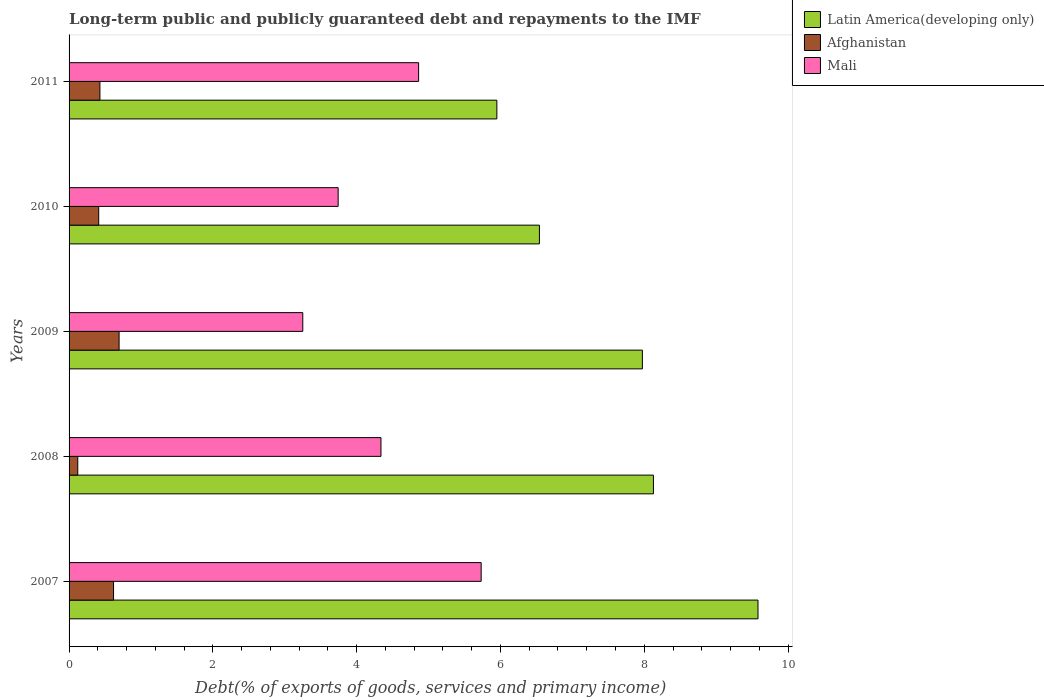How many groups of bars are there?
Make the answer very short. 5. Are the number of bars on each tick of the Y-axis equal?
Keep it short and to the point. Yes. What is the debt and repayments in Mali in 2007?
Keep it short and to the point. 5.73. Across all years, what is the maximum debt and repayments in Afghanistan?
Keep it short and to the point. 0.7. Across all years, what is the minimum debt and repayments in Latin America(developing only)?
Keep it short and to the point. 5.95. In which year was the debt and repayments in Mali maximum?
Provide a succinct answer. 2007. What is the total debt and repayments in Mali in the graph?
Offer a terse response. 21.92. What is the difference between the debt and repayments in Afghanistan in 2009 and that in 2011?
Your answer should be very brief. 0.27. What is the difference between the debt and repayments in Afghanistan in 2008 and the debt and repayments in Mali in 2007?
Ensure brevity in your answer.  -5.61. What is the average debt and repayments in Latin America(developing only) per year?
Your answer should be compact. 7.63. In the year 2009, what is the difference between the debt and repayments in Mali and debt and repayments in Latin America(developing only)?
Offer a terse response. -4.72. In how many years, is the debt and repayments in Afghanistan greater than 7.2 %?
Offer a terse response. 0. What is the ratio of the debt and repayments in Mali in 2008 to that in 2010?
Offer a terse response. 1.16. Is the difference between the debt and repayments in Mali in 2008 and 2009 greater than the difference between the debt and repayments in Latin America(developing only) in 2008 and 2009?
Provide a short and direct response. Yes. What is the difference between the highest and the second highest debt and repayments in Mali?
Your answer should be compact. 0.87. What is the difference between the highest and the lowest debt and repayments in Afghanistan?
Offer a terse response. 0.57. In how many years, is the debt and repayments in Afghanistan greater than the average debt and repayments in Afghanistan taken over all years?
Keep it short and to the point. 2. Is the sum of the debt and repayments in Latin America(developing only) in 2008 and 2010 greater than the maximum debt and repayments in Afghanistan across all years?
Ensure brevity in your answer.  Yes. What does the 1st bar from the top in 2010 represents?
Offer a very short reply. Mali. What does the 1st bar from the bottom in 2009 represents?
Your answer should be very brief. Latin America(developing only). How many bars are there?
Provide a succinct answer. 15. Where does the legend appear in the graph?
Keep it short and to the point. Top right. How are the legend labels stacked?
Make the answer very short. Vertical. What is the title of the graph?
Give a very brief answer. Long-term public and publicly guaranteed debt and repayments to the IMF. Does "Israel" appear as one of the legend labels in the graph?
Keep it short and to the point. No. What is the label or title of the X-axis?
Your answer should be very brief. Debt(% of exports of goods, services and primary income). What is the label or title of the Y-axis?
Give a very brief answer. Years. What is the Debt(% of exports of goods, services and primary income) of Latin America(developing only) in 2007?
Provide a short and direct response. 9.58. What is the Debt(% of exports of goods, services and primary income) of Afghanistan in 2007?
Your answer should be compact. 0.62. What is the Debt(% of exports of goods, services and primary income) of Mali in 2007?
Ensure brevity in your answer.  5.73. What is the Debt(% of exports of goods, services and primary income) of Latin America(developing only) in 2008?
Your response must be concise. 8.13. What is the Debt(% of exports of goods, services and primary income) in Afghanistan in 2008?
Make the answer very short. 0.12. What is the Debt(% of exports of goods, services and primary income) in Mali in 2008?
Your answer should be compact. 4.34. What is the Debt(% of exports of goods, services and primary income) of Latin America(developing only) in 2009?
Offer a terse response. 7.97. What is the Debt(% of exports of goods, services and primary income) in Afghanistan in 2009?
Make the answer very short. 0.7. What is the Debt(% of exports of goods, services and primary income) in Mali in 2009?
Offer a terse response. 3.25. What is the Debt(% of exports of goods, services and primary income) of Latin America(developing only) in 2010?
Provide a short and direct response. 6.54. What is the Debt(% of exports of goods, services and primary income) in Afghanistan in 2010?
Provide a succinct answer. 0.41. What is the Debt(% of exports of goods, services and primary income) of Mali in 2010?
Ensure brevity in your answer.  3.74. What is the Debt(% of exports of goods, services and primary income) of Latin America(developing only) in 2011?
Your response must be concise. 5.95. What is the Debt(% of exports of goods, services and primary income) in Afghanistan in 2011?
Make the answer very short. 0.43. What is the Debt(% of exports of goods, services and primary income) of Mali in 2011?
Your answer should be compact. 4.86. Across all years, what is the maximum Debt(% of exports of goods, services and primary income) in Latin America(developing only)?
Make the answer very short. 9.58. Across all years, what is the maximum Debt(% of exports of goods, services and primary income) in Afghanistan?
Your response must be concise. 0.7. Across all years, what is the maximum Debt(% of exports of goods, services and primary income) of Mali?
Your answer should be compact. 5.73. Across all years, what is the minimum Debt(% of exports of goods, services and primary income) of Latin America(developing only)?
Ensure brevity in your answer.  5.95. Across all years, what is the minimum Debt(% of exports of goods, services and primary income) in Afghanistan?
Provide a succinct answer. 0.12. Across all years, what is the minimum Debt(% of exports of goods, services and primary income) of Mali?
Give a very brief answer. 3.25. What is the total Debt(% of exports of goods, services and primary income) in Latin America(developing only) in the graph?
Make the answer very short. 38.17. What is the total Debt(% of exports of goods, services and primary income) in Afghanistan in the graph?
Your response must be concise. 2.28. What is the total Debt(% of exports of goods, services and primary income) of Mali in the graph?
Provide a succinct answer. 21.92. What is the difference between the Debt(% of exports of goods, services and primary income) in Latin America(developing only) in 2007 and that in 2008?
Provide a short and direct response. 1.45. What is the difference between the Debt(% of exports of goods, services and primary income) of Afghanistan in 2007 and that in 2008?
Provide a succinct answer. 0.5. What is the difference between the Debt(% of exports of goods, services and primary income) of Mali in 2007 and that in 2008?
Your answer should be compact. 1.39. What is the difference between the Debt(% of exports of goods, services and primary income) of Latin America(developing only) in 2007 and that in 2009?
Provide a short and direct response. 1.61. What is the difference between the Debt(% of exports of goods, services and primary income) in Afghanistan in 2007 and that in 2009?
Your answer should be very brief. -0.08. What is the difference between the Debt(% of exports of goods, services and primary income) of Mali in 2007 and that in 2009?
Your answer should be compact. 2.48. What is the difference between the Debt(% of exports of goods, services and primary income) in Latin America(developing only) in 2007 and that in 2010?
Your response must be concise. 3.04. What is the difference between the Debt(% of exports of goods, services and primary income) in Afghanistan in 2007 and that in 2010?
Your answer should be compact. 0.21. What is the difference between the Debt(% of exports of goods, services and primary income) of Mali in 2007 and that in 2010?
Provide a succinct answer. 1.99. What is the difference between the Debt(% of exports of goods, services and primary income) of Latin America(developing only) in 2007 and that in 2011?
Provide a short and direct response. 3.63. What is the difference between the Debt(% of exports of goods, services and primary income) of Afghanistan in 2007 and that in 2011?
Make the answer very short. 0.19. What is the difference between the Debt(% of exports of goods, services and primary income) in Mali in 2007 and that in 2011?
Your answer should be compact. 0.87. What is the difference between the Debt(% of exports of goods, services and primary income) of Latin America(developing only) in 2008 and that in 2009?
Provide a short and direct response. 0.15. What is the difference between the Debt(% of exports of goods, services and primary income) in Afghanistan in 2008 and that in 2009?
Offer a terse response. -0.57. What is the difference between the Debt(% of exports of goods, services and primary income) of Mali in 2008 and that in 2009?
Keep it short and to the point. 1.09. What is the difference between the Debt(% of exports of goods, services and primary income) of Latin America(developing only) in 2008 and that in 2010?
Ensure brevity in your answer.  1.59. What is the difference between the Debt(% of exports of goods, services and primary income) in Afghanistan in 2008 and that in 2010?
Provide a short and direct response. -0.29. What is the difference between the Debt(% of exports of goods, services and primary income) in Mali in 2008 and that in 2010?
Provide a succinct answer. 0.6. What is the difference between the Debt(% of exports of goods, services and primary income) in Latin America(developing only) in 2008 and that in 2011?
Your answer should be compact. 2.18. What is the difference between the Debt(% of exports of goods, services and primary income) of Afghanistan in 2008 and that in 2011?
Provide a short and direct response. -0.31. What is the difference between the Debt(% of exports of goods, services and primary income) of Mali in 2008 and that in 2011?
Provide a succinct answer. -0.52. What is the difference between the Debt(% of exports of goods, services and primary income) of Latin America(developing only) in 2009 and that in 2010?
Provide a short and direct response. 1.43. What is the difference between the Debt(% of exports of goods, services and primary income) of Afghanistan in 2009 and that in 2010?
Your answer should be compact. 0.28. What is the difference between the Debt(% of exports of goods, services and primary income) in Mali in 2009 and that in 2010?
Your answer should be compact. -0.49. What is the difference between the Debt(% of exports of goods, services and primary income) of Latin America(developing only) in 2009 and that in 2011?
Your answer should be compact. 2.02. What is the difference between the Debt(% of exports of goods, services and primary income) in Afghanistan in 2009 and that in 2011?
Provide a short and direct response. 0.27. What is the difference between the Debt(% of exports of goods, services and primary income) in Mali in 2009 and that in 2011?
Keep it short and to the point. -1.61. What is the difference between the Debt(% of exports of goods, services and primary income) in Latin America(developing only) in 2010 and that in 2011?
Your response must be concise. 0.59. What is the difference between the Debt(% of exports of goods, services and primary income) in Afghanistan in 2010 and that in 2011?
Your answer should be compact. -0.02. What is the difference between the Debt(% of exports of goods, services and primary income) of Mali in 2010 and that in 2011?
Give a very brief answer. -1.12. What is the difference between the Debt(% of exports of goods, services and primary income) of Latin America(developing only) in 2007 and the Debt(% of exports of goods, services and primary income) of Afghanistan in 2008?
Your response must be concise. 9.46. What is the difference between the Debt(% of exports of goods, services and primary income) of Latin America(developing only) in 2007 and the Debt(% of exports of goods, services and primary income) of Mali in 2008?
Offer a very short reply. 5.24. What is the difference between the Debt(% of exports of goods, services and primary income) of Afghanistan in 2007 and the Debt(% of exports of goods, services and primary income) of Mali in 2008?
Ensure brevity in your answer.  -3.72. What is the difference between the Debt(% of exports of goods, services and primary income) of Latin America(developing only) in 2007 and the Debt(% of exports of goods, services and primary income) of Afghanistan in 2009?
Your response must be concise. 8.89. What is the difference between the Debt(% of exports of goods, services and primary income) in Latin America(developing only) in 2007 and the Debt(% of exports of goods, services and primary income) in Mali in 2009?
Provide a short and direct response. 6.33. What is the difference between the Debt(% of exports of goods, services and primary income) in Afghanistan in 2007 and the Debt(% of exports of goods, services and primary income) in Mali in 2009?
Your answer should be very brief. -2.63. What is the difference between the Debt(% of exports of goods, services and primary income) in Latin America(developing only) in 2007 and the Debt(% of exports of goods, services and primary income) in Afghanistan in 2010?
Make the answer very short. 9.17. What is the difference between the Debt(% of exports of goods, services and primary income) of Latin America(developing only) in 2007 and the Debt(% of exports of goods, services and primary income) of Mali in 2010?
Give a very brief answer. 5.84. What is the difference between the Debt(% of exports of goods, services and primary income) in Afghanistan in 2007 and the Debt(% of exports of goods, services and primary income) in Mali in 2010?
Your response must be concise. -3.12. What is the difference between the Debt(% of exports of goods, services and primary income) in Latin America(developing only) in 2007 and the Debt(% of exports of goods, services and primary income) in Afghanistan in 2011?
Offer a very short reply. 9.15. What is the difference between the Debt(% of exports of goods, services and primary income) in Latin America(developing only) in 2007 and the Debt(% of exports of goods, services and primary income) in Mali in 2011?
Keep it short and to the point. 4.72. What is the difference between the Debt(% of exports of goods, services and primary income) in Afghanistan in 2007 and the Debt(% of exports of goods, services and primary income) in Mali in 2011?
Your answer should be very brief. -4.24. What is the difference between the Debt(% of exports of goods, services and primary income) in Latin America(developing only) in 2008 and the Debt(% of exports of goods, services and primary income) in Afghanistan in 2009?
Your response must be concise. 7.43. What is the difference between the Debt(% of exports of goods, services and primary income) of Latin America(developing only) in 2008 and the Debt(% of exports of goods, services and primary income) of Mali in 2009?
Provide a succinct answer. 4.88. What is the difference between the Debt(% of exports of goods, services and primary income) in Afghanistan in 2008 and the Debt(% of exports of goods, services and primary income) in Mali in 2009?
Provide a short and direct response. -3.13. What is the difference between the Debt(% of exports of goods, services and primary income) in Latin America(developing only) in 2008 and the Debt(% of exports of goods, services and primary income) in Afghanistan in 2010?
Offer a very short reply. 7.72. What is the difference between the Debt(% of exports of goods, services and primary income) of Latin America(developing only) in 2008 and the Debt(% of exports of goods, services and primary income) of Mali in 2010?
Provide a succinct answer. 4.38. What is the difference between the Debt(% of exports of goods, services and primary income) of Afghanistan in 2008 and the Debt(% of exports of goods, services and primary income) of Mali in 2010?
Give a very brief answer. -3.62. What is the difference between the Debt(% of exports of goods, services and primary income) in Latin America(developing only) in 2008 and the Debt(% of exports of goods, services and primary income) in Afghanistan in 2011?
Provide a succinct answer. 7.7. What is the difference between the Debt(% of exports of goods, services and primary income) in Latin America(developing only) in 2008 and the Debt(% of exports of goods, services and primary income) in Mali in 2011?
Offer a terse response. 3.27. What is the difference between the Debt(% of exports of goods, services and primary income) of Afghanistan in 2008 and the Debt(% of exports of goods, services and primary income) of Mali in 2011?
Offer a very short reply. -4.74. What is the difference between the Debt(% of exports of goods, services and primary income) in Latin America(developing only) in 2009 and the Debt(% of exports of goods, services and primary income) in Afghanistan in 2010?
Your response must be concise. 7.56. What is the difference between the Debt(% of exports of goods, services and primary income) of Latin America(developing only) in 2009 and the Debt(% of exports of goods, services and primary income) of Mali in 2010?
Offer a very short reply. 4.23. What is the difference between the Debt(% of exports of goods, services and primary income) in Afghanistan in 2009 and the Debt(% of exports of goods, services and primary income) in Mali in 2010?
Offer a very short reply. -3.05. What is the difference between the Debt(% of exports of goods, services and primary income) in Latin America(developing only) in 2009 and the Debt(% of exports of goods, services and primary income) in Afghanistan in 2011?
Offer a very short reply. 7.54. What is the difference between the Debt(% of exports of goods, services and primary income) in Latin America(developing only) in 2009 and the Debt(% of exports of goods, services and primary income) in Mali in 2011?
Your answer should be compact. 3.11. What is the difference between the Debt(% of exports of goods, services and primary income) in Afghanistan in 2009 and the Debt(% of exports of goods, services and primary income) in Mali in 2011?
Your answer should be very brief. -4.17. What is the difference between the Debt(% of exports of goods, services and primary income) in Latin America(developing only) in 2010 and the Debt(% of exports of goods, services and primary income) in Afghanistan in 2011?
Provide a short and direct response. 6.11. What is the difference between the Debt(% of exports of goods, services and primary income) of Latin America(developing only) in 2010 and the Debt(% of exports of goods, services and primary income) of Mali in 2011?
Your response must be concise. 1.68. What is the difference between the Debt(% of exports of goods, services and primary income) in Afghanistan in 2010 and the Debt(% of exports of goods, services and primary income) in Mali in 2011?
Ensure brevity in your answer.  -4.45. What is the average Debt(% of exports of goods, services and primary income) in Latin America(developing only) per year?
Make the answer very short. 7.63. What is the average Debt(% of exports of goods, services and primary income) of Afghanistan per year?
Keep it short and to the point. 0.46. What is the average Debt(% of exports of goods, services and primary income) of Mali per year?
Ensure brevity in your answer.  4.38. In the year 2007, what is the difference between the Debt(% of exports of goods, services and primary income) of Latin America(developing only) and Debt(% of exports of goods, services and primary income) of Afghanistan?
Offer a very short reply. 8.96. In the year 2007, what is the difference between the Debt(% of exports of goods, services and primary income) of Latin America(developing only) and Debt(% of exports of goods, services and primary income) of Mali?
Make the answer very short. 3.85. In the year 2007, what is the difference between the Debt(% of exports of goods, services and primary income) of Afghanistan and Debt(% of exports of goods, services and primary income) of Mali?
Offer a terse response. -5.11. In the year 2008, what is the difference between the Debt(% of exports of goods, services and primary income) of Latin America(developing only) and Debt(% of exports of goods, services and primary income) of Afghanistan?
Ensure brevity in your answer.  8.01. In the year 2008, what is the difference between the Debt(% of exports of goods, services and primary income) of Latin America(developing only) and Debt(% of exports of goods, services and primary income) of Mali?
Your answer should be very brief. 3.79. In the year 2008, what is the difference between the Debt(% of exports of goods, services and primary income) of Afghanistan and Debt(% of exports of goods, services and primary income) of Mali?
Give a very brief answer. -4.22. In the year 2009, what is the difference between the Debt(% of exports of goods, services and primary income) in Latin America(developing only) and Debt(% of exports of goods, services and primary income) in Afghanistan?
Keep it short and to the point. 7.28. In the year 2009, what is the difference between the Debt(% of exports of goods, services and primary income) in Latin America(developing only) and Debt(% of exports of goods, services and primary income) in Mali?
Your answer should be compact. 4.72. In the year 2009, what is the difference between the Debt(% of exports of goods, services and primary income) of Afghanistan and Debt(% of exports of goods, services and primary income) of Mali?
Give a very brief answer. -2.55. In the year 2010, what is the difference between the Debt(% of exports of goods, services and primary income) in Latin America(developing only) and Debt(% of exports of goods, services and primary income) in Afghanistan?
Provide a short and direct response. 6.13. In the year 2010, what is the difference between the Debt(% of exports of goods, services and primary income) of Latin America(developing only) and Debt(% of exports of goods, services and primary income) of Mali?
Your response must be concise. 2.8. In the year 2010, what is the difference between the Debt(% of exports of goods, services and primary income) in Afghanistan and Debt(% of exports of goods, services and primary income) in Mali?
Make the answer very short. -3.33. In the year 2011, what is the difference between the Debt(% of exports of goods, services and primary income) of Latin America(developing only) and Debt(% of exports of goods, services and primary income) of Afghanistan?
Provide a succinct answer. 5.52. In the year 2011, what is the difference between the Debt(% of exports of goods, services and primary income) of Latin America(developing only) and Debt(% of exports of goods, services and primary income) of Mali?
Provide a short and direct response. 1.09. In the year 2011, what is the difference between the Debt(% of exports of goods, services and primary income) in Afghanistan and Debt(% of exports of goods, services and primary income) in Mali?
Provide a short and direct response. -4.43. What is the ratio of the Debt(% of exports of goods, services and primary income) in Latin America(developing only) in 2007 to that in 2008?
Make the answer very short. 1.18. What is the ratio of the Debt(% of exports of goods, services and primary income) of Afghanistan in 2007 to that in 2008?
Provide a succinct answer. 5.11. What is the ratio of the Debt(% of exports of goods, services and primary income) of Mali in 2007 to that in 2008?
Your response must be concise. 1.32. What is the ratio of the Debt(% of exports of goods, services and primary income) of Latin America(developing only) in 2007 to that in 2009?
Make the answer very short. 1.2. What is the ratio of the Debt(% of exports of goods, services and primary income) in Afghanistan in 2007 to that in 2009?
Your answer should be very brief. 0.89. What is the ratio of the Debt(% of exports of goods, services and primary income) of Mali in 2007 to that in 2009?
Keep it short and to the point. 1.76. What is the ratio of the Debt(% of exports of goods, services and primary income) of Latin America(developing only) in 2007 to that in 2010?
Your answer should be very brief. 1.46. What is the ratio of the Debt(% of exports of goods, services and primary income) of Afghanistan in 2007 to that in 2010?
Offer a terse response. 1.5. What is the ratio of the Debt(% of exports of goods, services and primary income) in Mali in 2007 to that in 2010?
Provide a succinct answer. 1.53. What is the ratio of the Debt(% of exports of goods, services and primary income) of Latin America(developing only) in 2007 to that in 2011?
Ensure brevity in your answer.  1.61. What is the ratio of the Debt(% of exports of goods, services and primary income) of Afghanistan in 2007 to that in 2011?
Your answer should be compact. 1.44. What is the ratio of the Debt(% of exports of goods, services and primary income) of Mali in 2007 to that in 2011?
Offer a very short reply. 1.18. What is the ratio of the Debt(% of exports of goods, services and primary income) of Latin America(developing only) in 2008 to that in 2009?
Give a very brief answer. 1.02. What is the ratio of the Debt(% of exports of goods, services and primary income) of Afghanistan in 2008 to that in 2009?
Give a very brief answer. 0.17. What is the ratio of the Debt(% of exports of goods, services and primary income) in Mali in 2008 to that in 2009?
Make the answer very short. 1.33. What is the ratio of the Debt(% of exports of goods, services and primary income) in Latin America(developing only) in 2008 to that in 2010?
Provide a succinct answer. 1.24. What is the ratio of the Debt(% of exports of goods, services and primary income) in Afghanistan in 2008 to that in 2010?
Offer a terse response. 0.29. What is the ratio of the Debt(% of exports of goods, services and primary income) of Mali in 2008 to that in 2010?
Provide a succinct answer. 1.16. What is the ratio of the Debt(% of exports of goods, services and primary income) in Latin America(developing only) in 2008 to that in 2011?
Offer a very short reply. 1.37. What is the ratio of the Debt(% of exports of goods, services and primary income) of Afghanistan in 2008 to that in 2011?
Your response must be concise. 0.28. What is the ratio of the Debt(% of exports of goods, services and primary income) of Mali in 2008 to that in 2011?
Make the answer very short. 0.89. What is the ratio of the Debt(% of exports of goods, services and primary income) in Latin America(developing only) in 2009 to that in 2010?
Give a very brief answer. 1.22. What is the ratio of the Debt(% of exports of goods, services and primary income) of Afghanistan in 2009 to that in 2010?
Keep it short and to the point. 1.69. What is the ratio of the Debt(% of exports of goods, services and primary income) of Mali in 2009 to that in 2010?
Your answer should be compact. 0.87. What is the ratio of the Debt(% of exports of goods, services and primary income) of Latin America(developing only) in 2009 to that in 2011?
Keep it short and to the point. 1.34. What is the ratio of the Debt(% of exports of goods, services and primary income) in Afghanistan in 2009 to that in 2011?
Give a very brief answer. 1.62. What is the ratio of the Debt(% of exports of goods, services and primary income) of Mali in 2009 to that in 2011?
Give a very brief answer. 0.67. What is the ratio of the Debt(% of exports of goods, services and primary income) in Latin America(developing only) in 2010 to that in 2011?
Offer a very short reply. 1.1. What is the ratio of the Debt(% of exports of goods, services and primary income) in Afghanistan in 2010 to that in 2011?
Keep it short and to the point. 0.96. What is the ratio of the Debt(% of exports of goods, services and primary income) in Mali in 2010 to that in 2011?
Make the answer very short. 0.77. What is the difference between the highest and the second highest Debt(% of exports of goods, services and primary income) in Latin America(developing only)?
Your answer should be very brief. 1.45. What is the difference between the highest and the second highest Debt(% of exports of goods, services and primary income) of Afghanistan?
Ensure brevity in your answer.  0.08. What is the difference between the highest and the second highest Debt(% of exports of goods, services and primary income) of Mali?
Offer a very short reply. 0.87. What is the difference between the highest and the lowest Debt(% of exports of goods, services and primary income) in Latin America(developing only)?
Ensure brevity in your answer.  3.63. What is the difference between the highest and the lowest Debt(% of exports of goods, services and primary income) of Afghanistan?
Your response must be concise. 0.57. What is the difference between the highest and the lowest Debt(% of exports of goods, services and primary income) of Mali?
Offer a terse response. 2.48. 